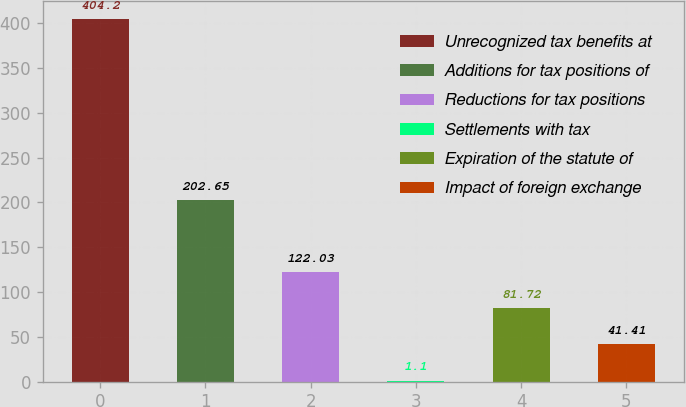<chart> <loc_0><loc_0><loc_500><loc_500><bar_chart><fcel>Unrecognized tax benefits at<fcel>Additions for tax positions of<fcel>Reductions for tax positions<fcel>Settlements with tax<fcel>Expiration of the statute of<fcel>Impact of foreign exchange<nl><fcel>404.2<fcel>202.65<fcel>122.03<fcel>1.1<fcel>81.72<fcel>41.41<nl></chart> 